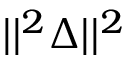<formula> <loc_0><loc_0><loc_500><loc_500>| | ^ { 2 } { \Delta } | | ^ { 2 }</formula> 